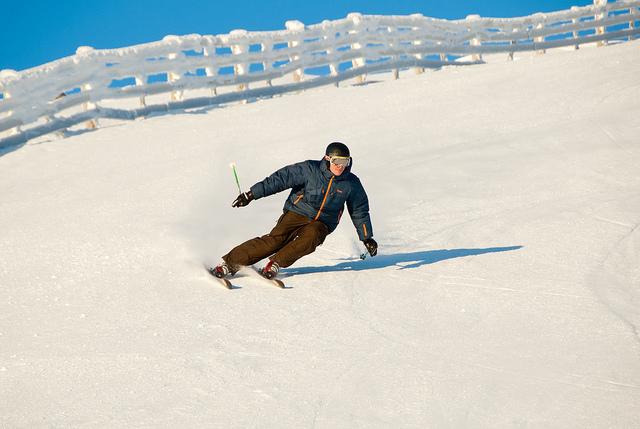Is the person skiing?
Keep it brief. Yes. What is on the fence?
Quick response, please. Snow. What season is depicted in the photography?
Be succinct. Winter. 